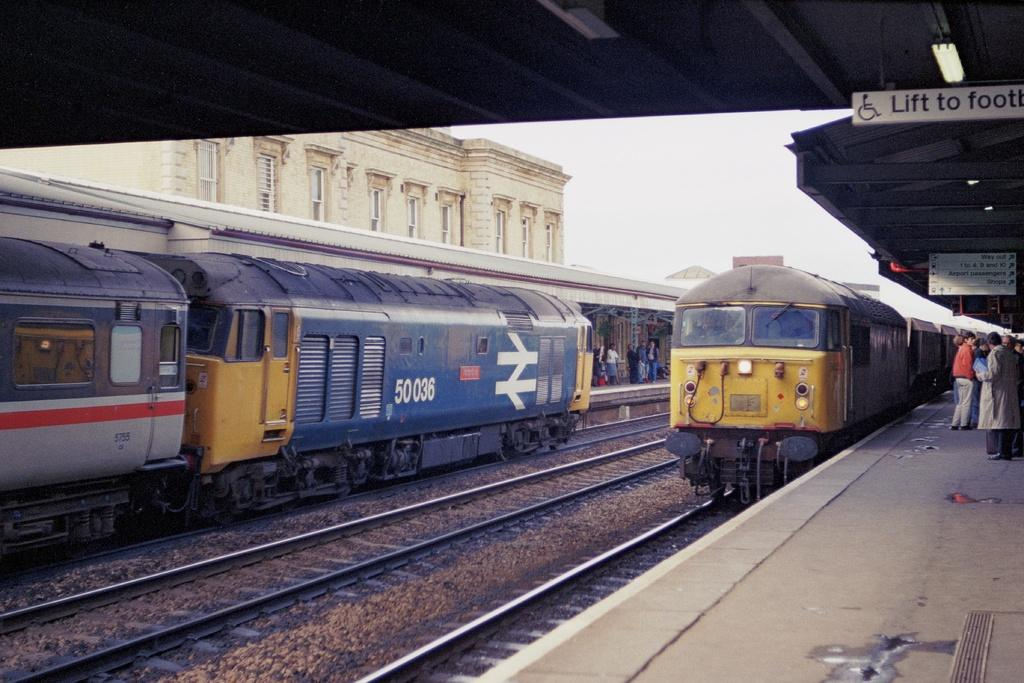<image>
Summarize the visual content of the image. Train car number 50 036 is at the station along with some other cars. 